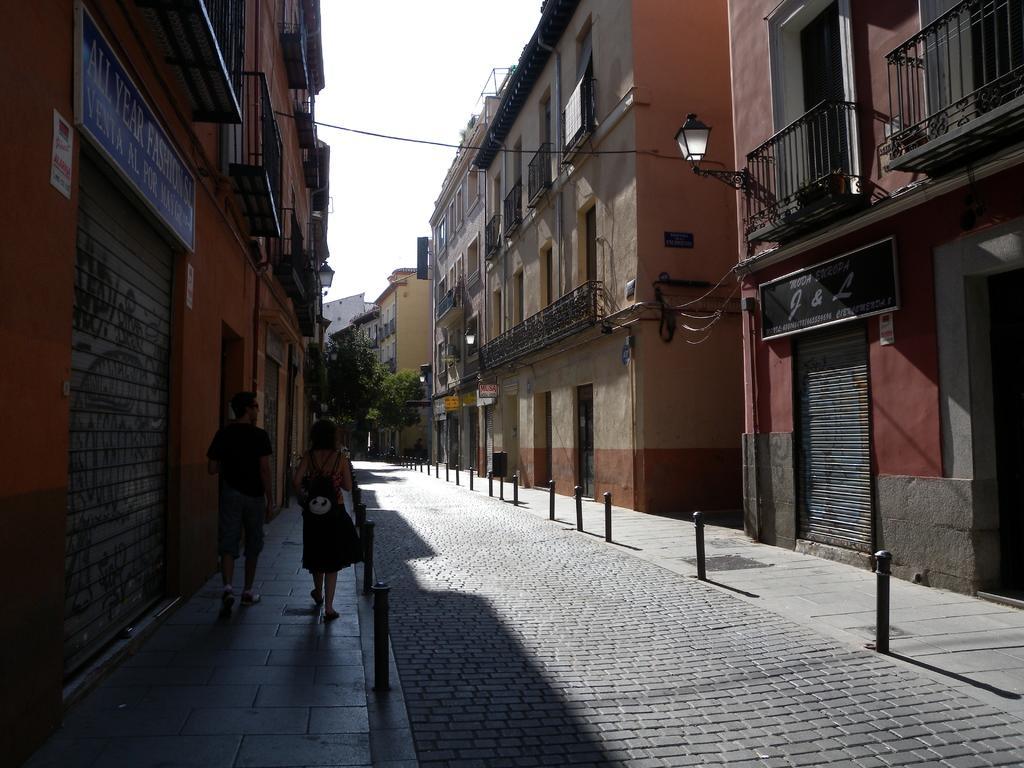Could you give a brief overview of what you see in this image? In this image we can see there are two persons walking on the pavement of the road and there are a few rods on the either sides of the road. On the right and left side of the image there are buildings and trees. In the background there is a sky. 